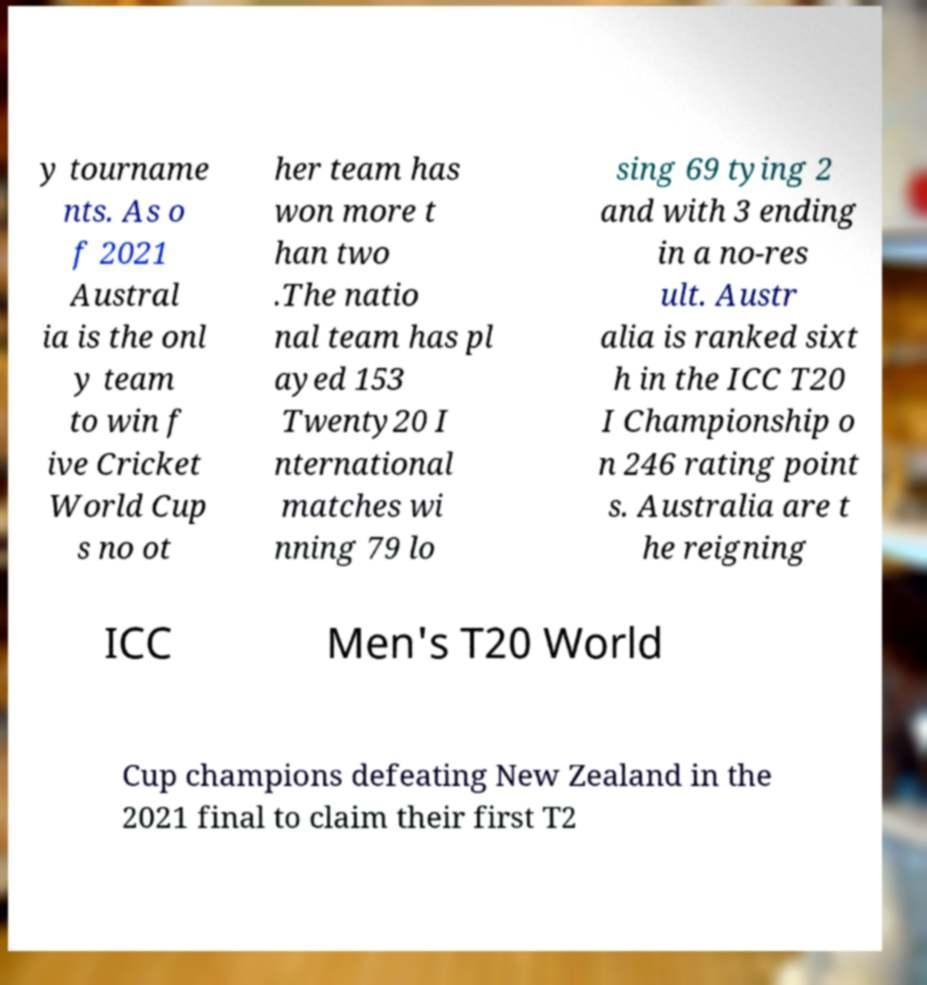Please identify and transcribe the text found in this image. y tourname nts. As o f 2021 Austral ia is the onl y team to win f ive Cricket World Cup s no ot her team has won more t han two .The natio nal team has pl ayed 153 Twenty20 I nternational matches wi nning 79 lo sing 69 tying 2 and with 3 ending in a no-res ult. Austr alia is ranked sixt h in the ICC T20 I Championship o n 246 rating point s. Australia are t he reigning ICC Men's T20 World Cup champions defeating New Zealand in the 2021 final to claim their first T2 